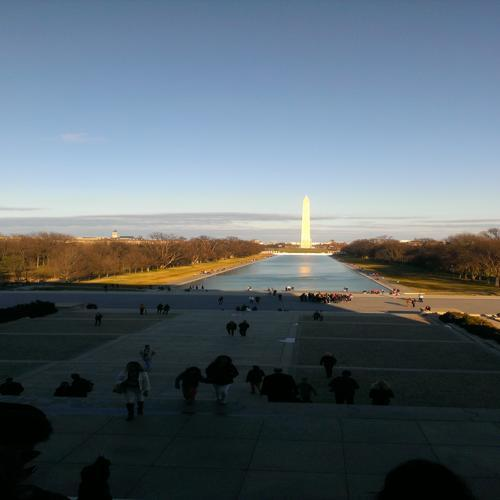Can you describe the historical significance of this structure? The structure in the image is a significant monument that stands as a symbol of an important historical figure's leadership and contributions. Its presence often evokes a sense of national pride and serves as a place for reflection on the values and history it represents. What are some notable features of the surrounding landscape? The surrounding landscape features a long, reflecting pool that creates a visual pathway leading to the monument. The open spaces around it are often used for gatherings, demonstrations, and public events. The well-maintained lawns and the alignment with other significant landmarks contribute to its grandeur and symbolic meaning. 